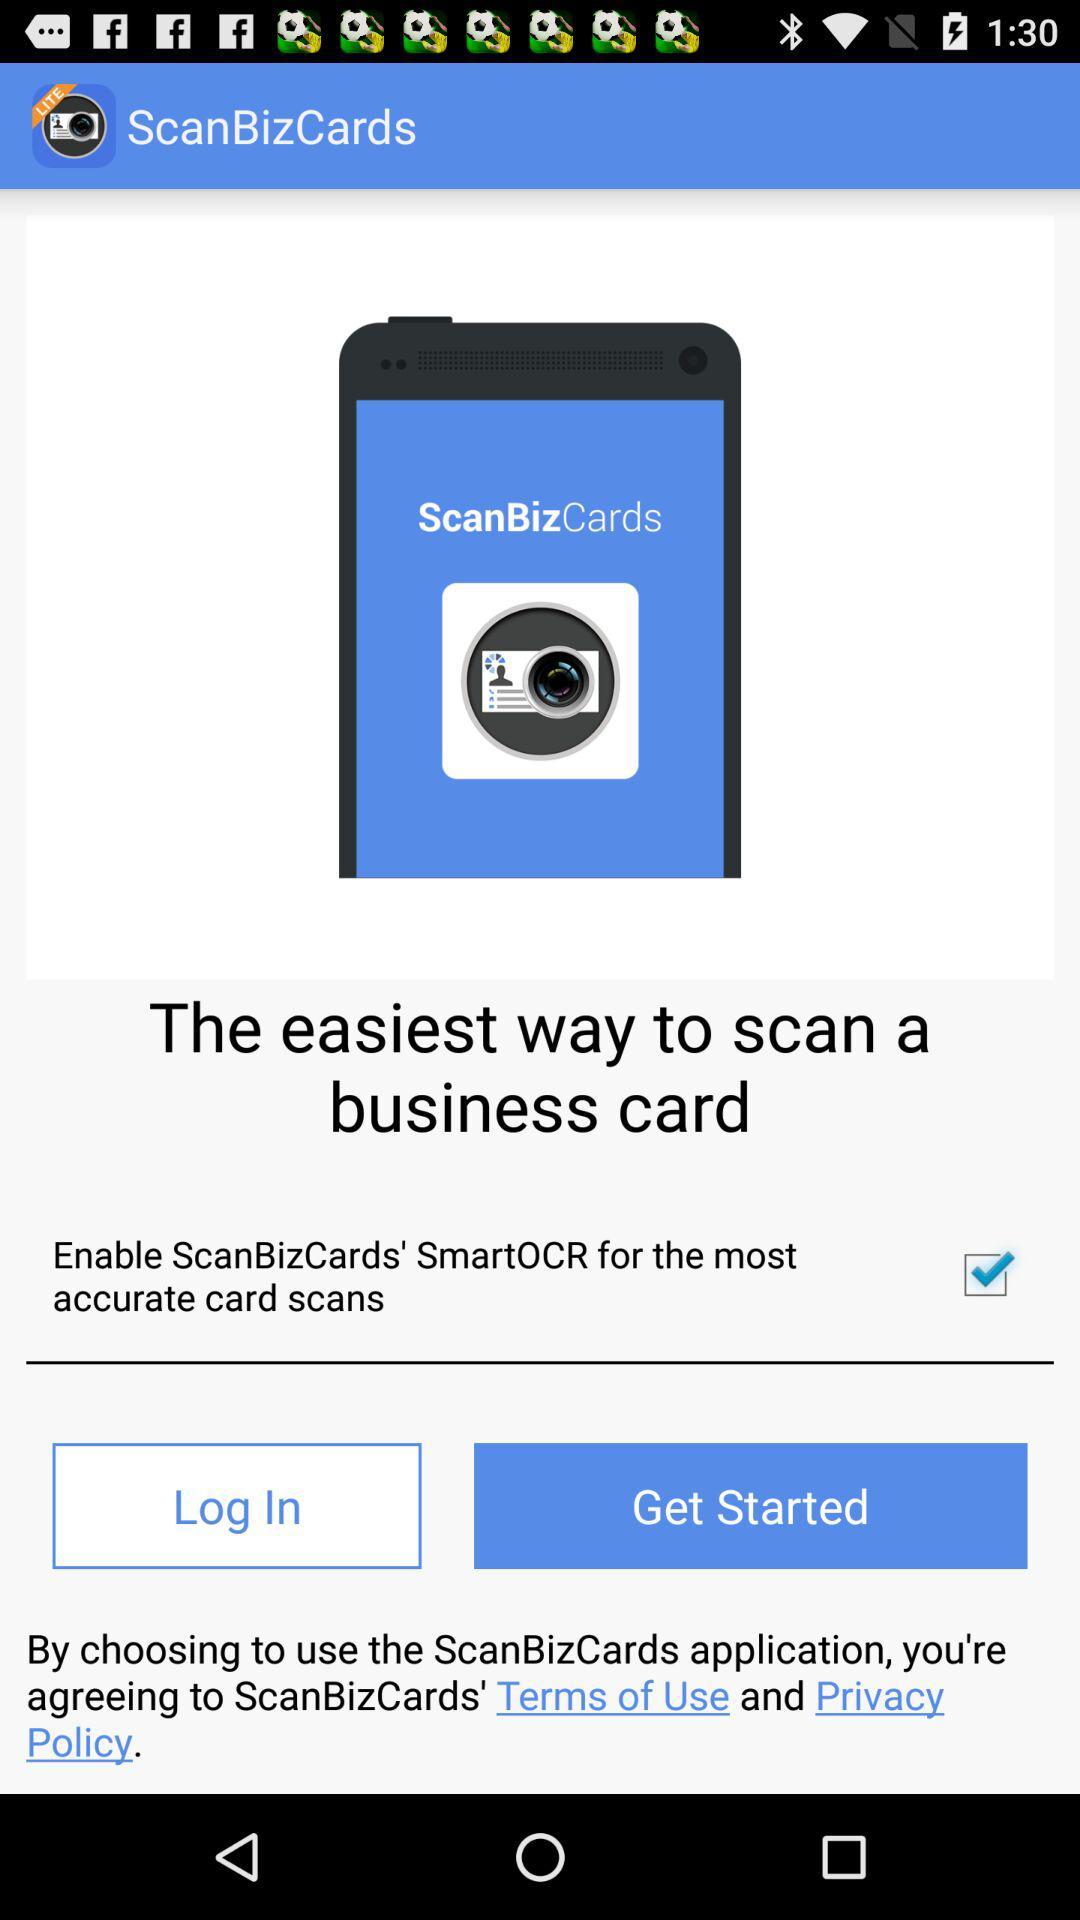What is the checked checkbox? The checked checkbox is "Enable ScanBizCards' SmartOCR for the most accurate card scans". 